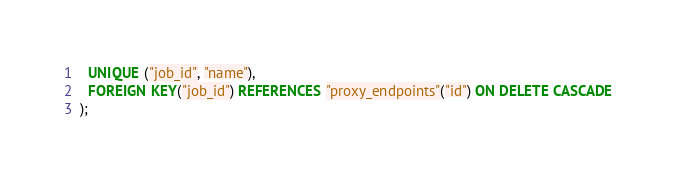<code> <loc_0><loc_0><loc_500><loc_500><_SQL_>  UNIQUE ("job_id", "name"),
  FOREIGN KEY("job_id") REFERENCES "proxy_endpoints"("id") ON DELETE CASCADE
);
</code> 